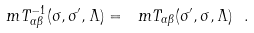Convert formula to latex. <formula><loc_0><loc_0><loc_500><loc_500>\ m T ^ { - 1 } _ { \alpha \beta } ( \sigma , \sigma ^ { \prime } , \Lambda ) = \ m T _ { \alpha \beta } ( \sigma ^ { \prime } , \sigma , \Lambda ) \ .</formula> 